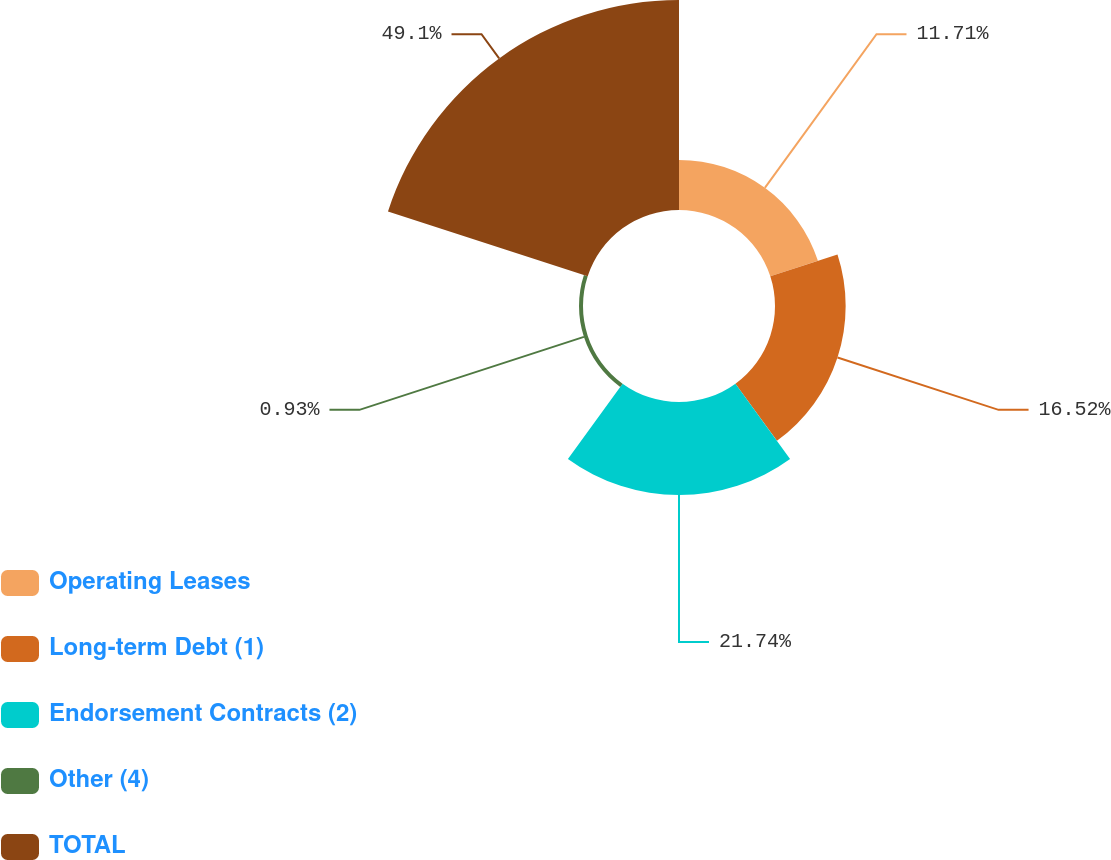Convert chart to OTSL. <chart><loc_0><loc_0><loc_500><loc_500><pie_chart><fcel>Operating Leases<fcel>Long-term Debt (1)<fcel>Endorsement Contracts (2)<fcel>Other (4)<fcel>TOTAL<nl><fcel>11.71%<fcel>16.52%<fcel>21.74%<fcel>0.93%<fcel>49.1%<nl></chart> 